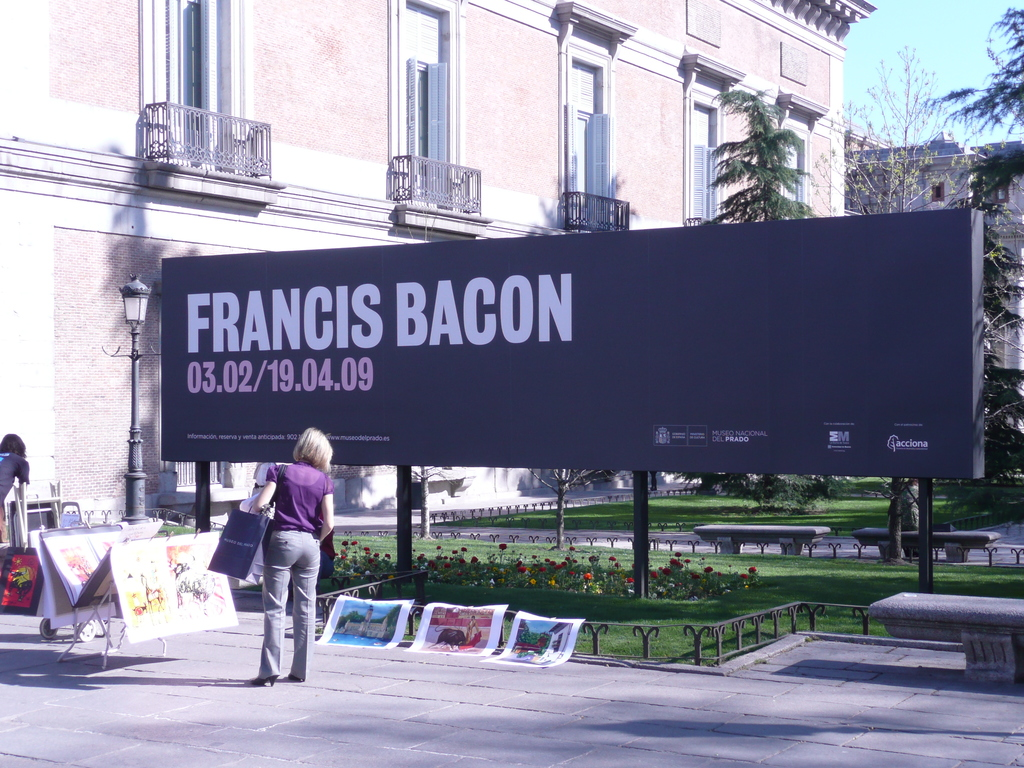How does the presence of art vendors near museum exhibitions like this affect the art culture in the area? Art vendors near museum exhibitions contribute to a vibrant art culture, making art more accessible to the public and creating a lively atmosphere that encourages art appreciation and discussion among a wider audience. Could this accessibility affect the perceived value of the artwork being sold? Yes, increased accessibility might democratize art ownership but could also lead to varied perceptions of value, where some might see it as diminishing exclusivity, while others appreciate the broadened engagement and opportunity to own art. 